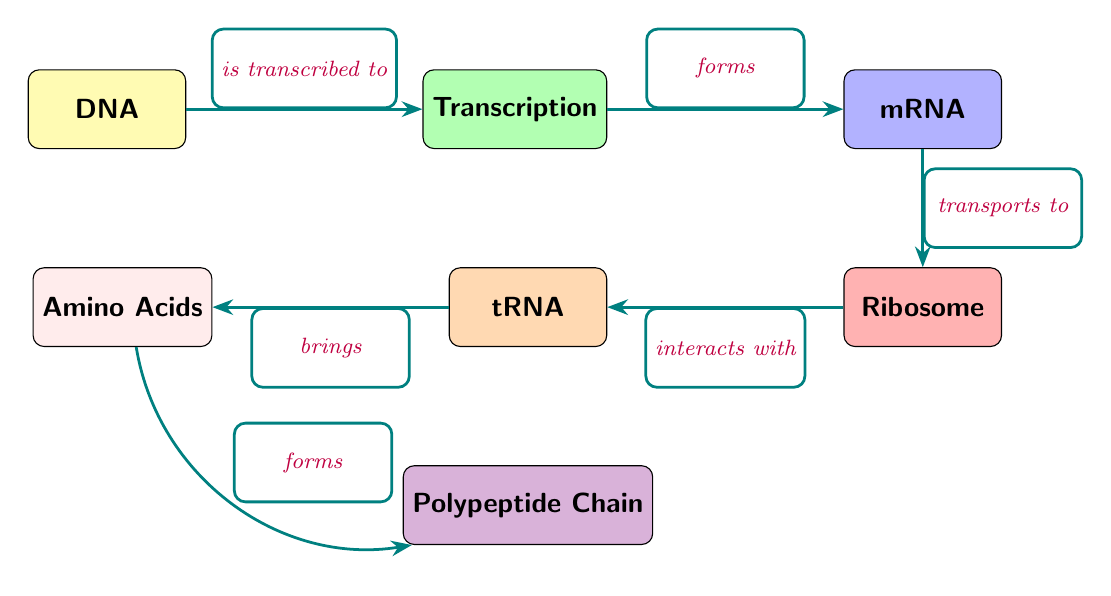What is the initial molecule in the diagram? The diagram starts with DNA, which is the first node on the left.
Answer: DNA What process occurs between DNA and mRNA? The diagram indicates that the process of transcription occurs, connecting the DNA node to the mRNA node.
Answer: Transcription How many nodes are present in the diagram? There are a total of 7 nodes represented in the diagram, including DNA, Transcription, mRNA, Ribosome, tRNA, Amino Acids, and Polypeptide Chain.
Answer: 7 What does tRNA interact with in the diagram? The diagram shows that tRNA interacts with the Ribosome, which is illustrated as the node located below mRNA.
Answer: Ribosome What is formed after Amino Acids according to the diagram? Following the Amino Acids node, the diagram indicates that a Polypeptide Chain is formed, as indicated by the edge connecting these two nodes.
Answer: Polypeptide Chain What is the directional flow of information from mRNA to Ribosome? The information flows from the mRNA node to the Ribosome node, which is indicated by the arrow labeled "transports to".
Answer: transports to How do Amino Acids relate to Polypeptide Chain? The diagram shows that Amino Acids bring together to ultimately form a Polypeptide Chain, which is represented by the edge labeled "forms".
Answer: forms Which color represents the tRNA node in the diagram? The tRNA node is colored in orange according to the visual representation in the diagram.
Answer: orange What type of diagram is this and what does it illustrate? This is a textbook diagram that illustrates the steps of genetic code translation from DNA to protein synthesis.
Answer: textbook diagram 